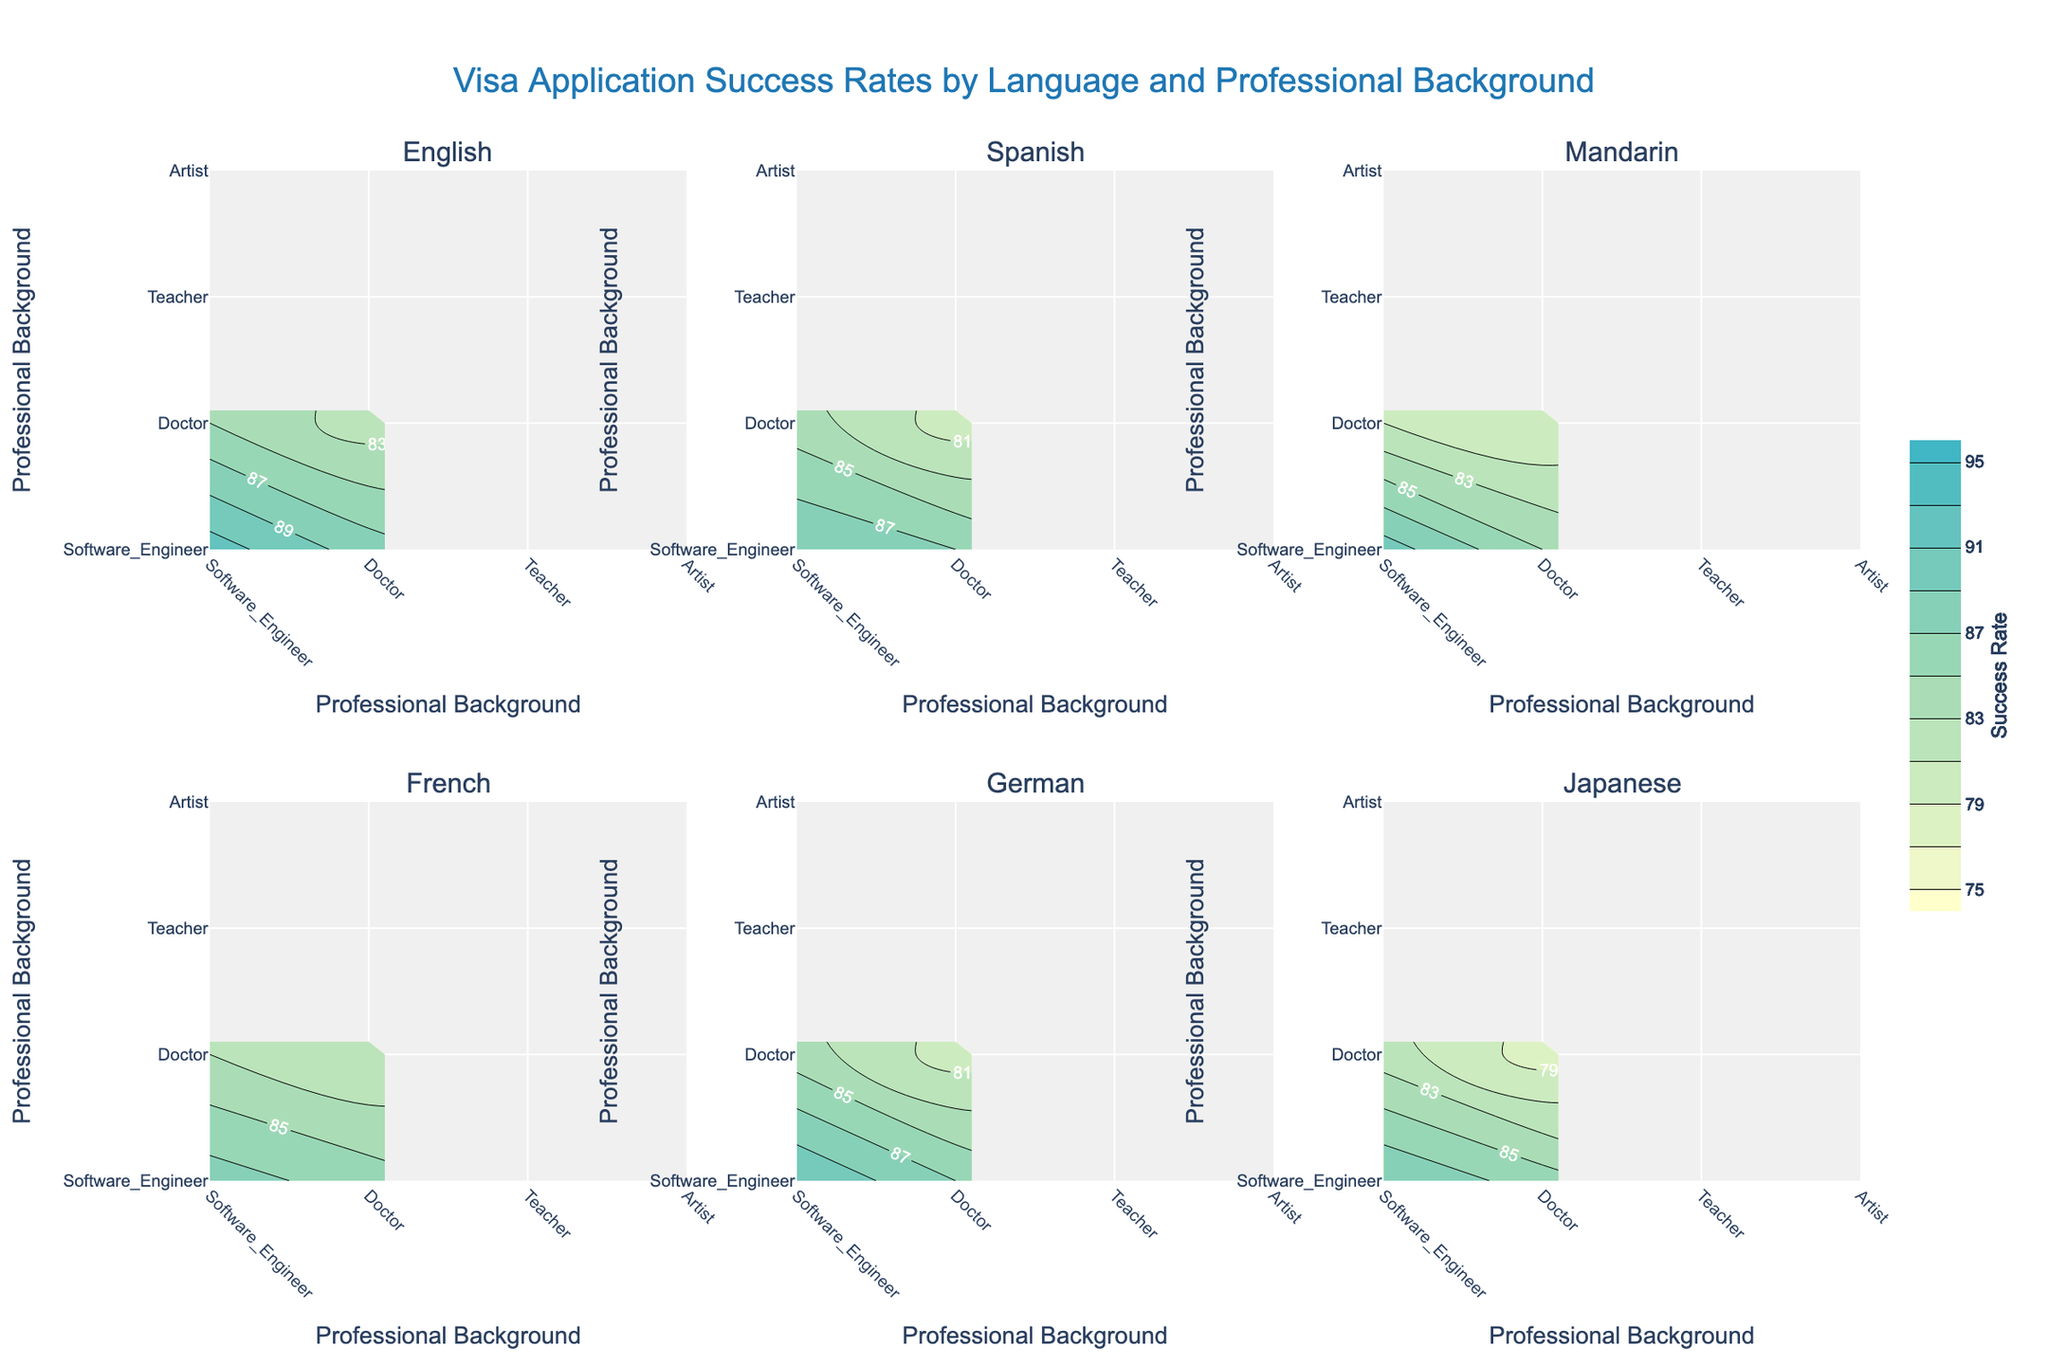What is the title of the plot? The title is centrally placed at the top of the figure and reads "Visa Application Success Rates by Language and Professional Background."
Answer: Visa Application Success Rates by Language and Professional Background Which professional background has the highest success rate for English interviews? By looking at the contour plot for English, the success rate for Software Engineers is the highest among the professional backgrounds shown.
Answer: Software Engineers How many subplots are there in the figure? The figure contains subplots for each interview language, and there are six languages, resulting in six subplots in total.
Answer: Six What is the range for the success rates represented by the color scale? The color scale starts at a light yellow color for a 75% success rate and goes up to a darker blue color for a 95% success rate, as indicated by the contour lines and the color bar.
Answer: 75% to 95% Which interview language has the lowest success rate for Artists? In the subplot for Japanese, Artists have the lowest success rate compared to other professional backgrounds.
Answer: Japanese Which profession shows a consistent success rate across all interview languages? Throughout the subplots for different languages, the success rate for Doctors remains around 86-88%, which is relatively consistent across all subplots.
Answer: Doctors Compare the success rate for Teachers interviewing in English to those interviewing in German. The subplot for English shows a success rate of 85% for Teachers, while the subplot for German shows a success rate of 84%.
Answer: Teachers have a higher success rate in English interviews compared to German interviews What professional background has the general highest success rate across all languages? By observing all subplots, Software Engineers typically exhibit the highest success rates across different languages.
Answer: Software Engineers Which interview language shows the overall highest visa application success rate? Analyzing the subplots, English interviews have the highest success rates across various professional backgrounds compared to other languages.
Answer: English 